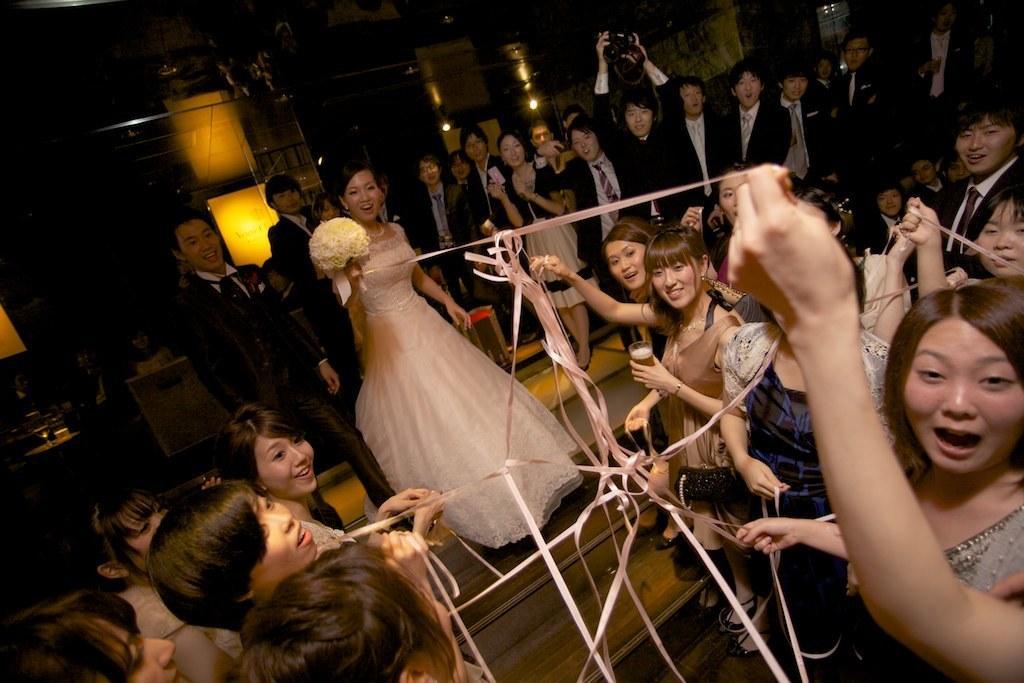Describe this image in one or two sentences. In this image there are many people standing. In the center there is a woman holding a flower bouquet in her hand. At the bottom there the woman holding ribbons in their hands. In the background there are people standing. In the background there is a wall. 